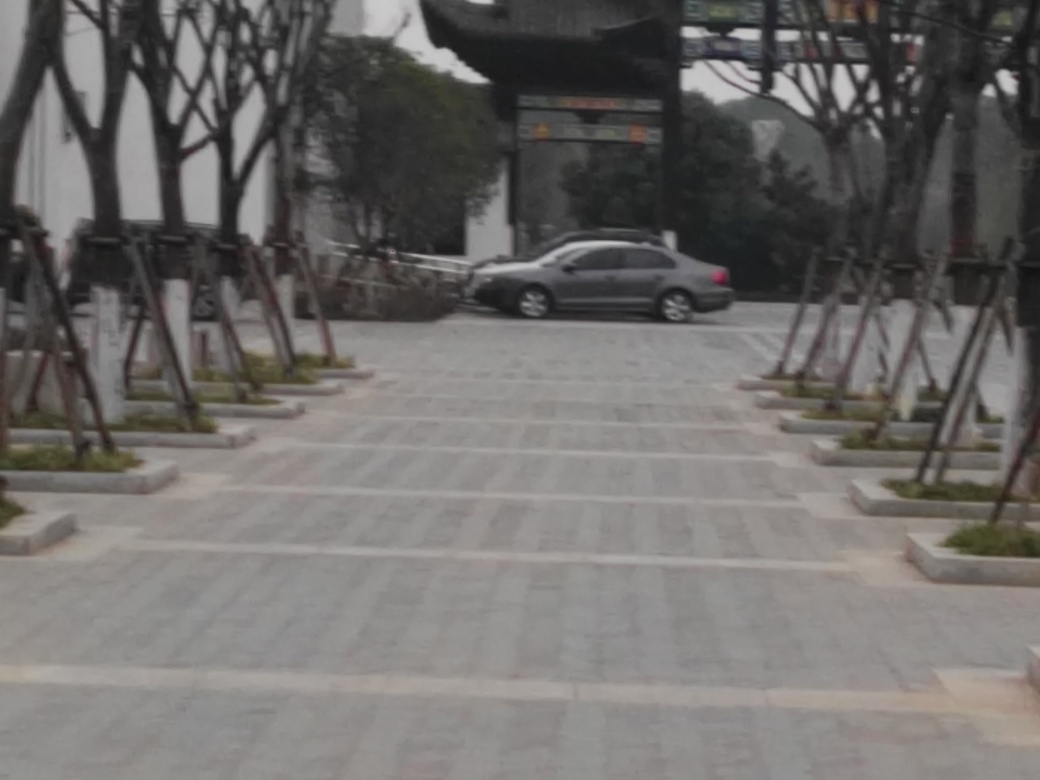What can we infer about the location from this image? The presence of trees carefully supported by wooden stakes and the orderly arrangement of the paving suggest a well-maintained public space or park area, possibly in an urban setting. 